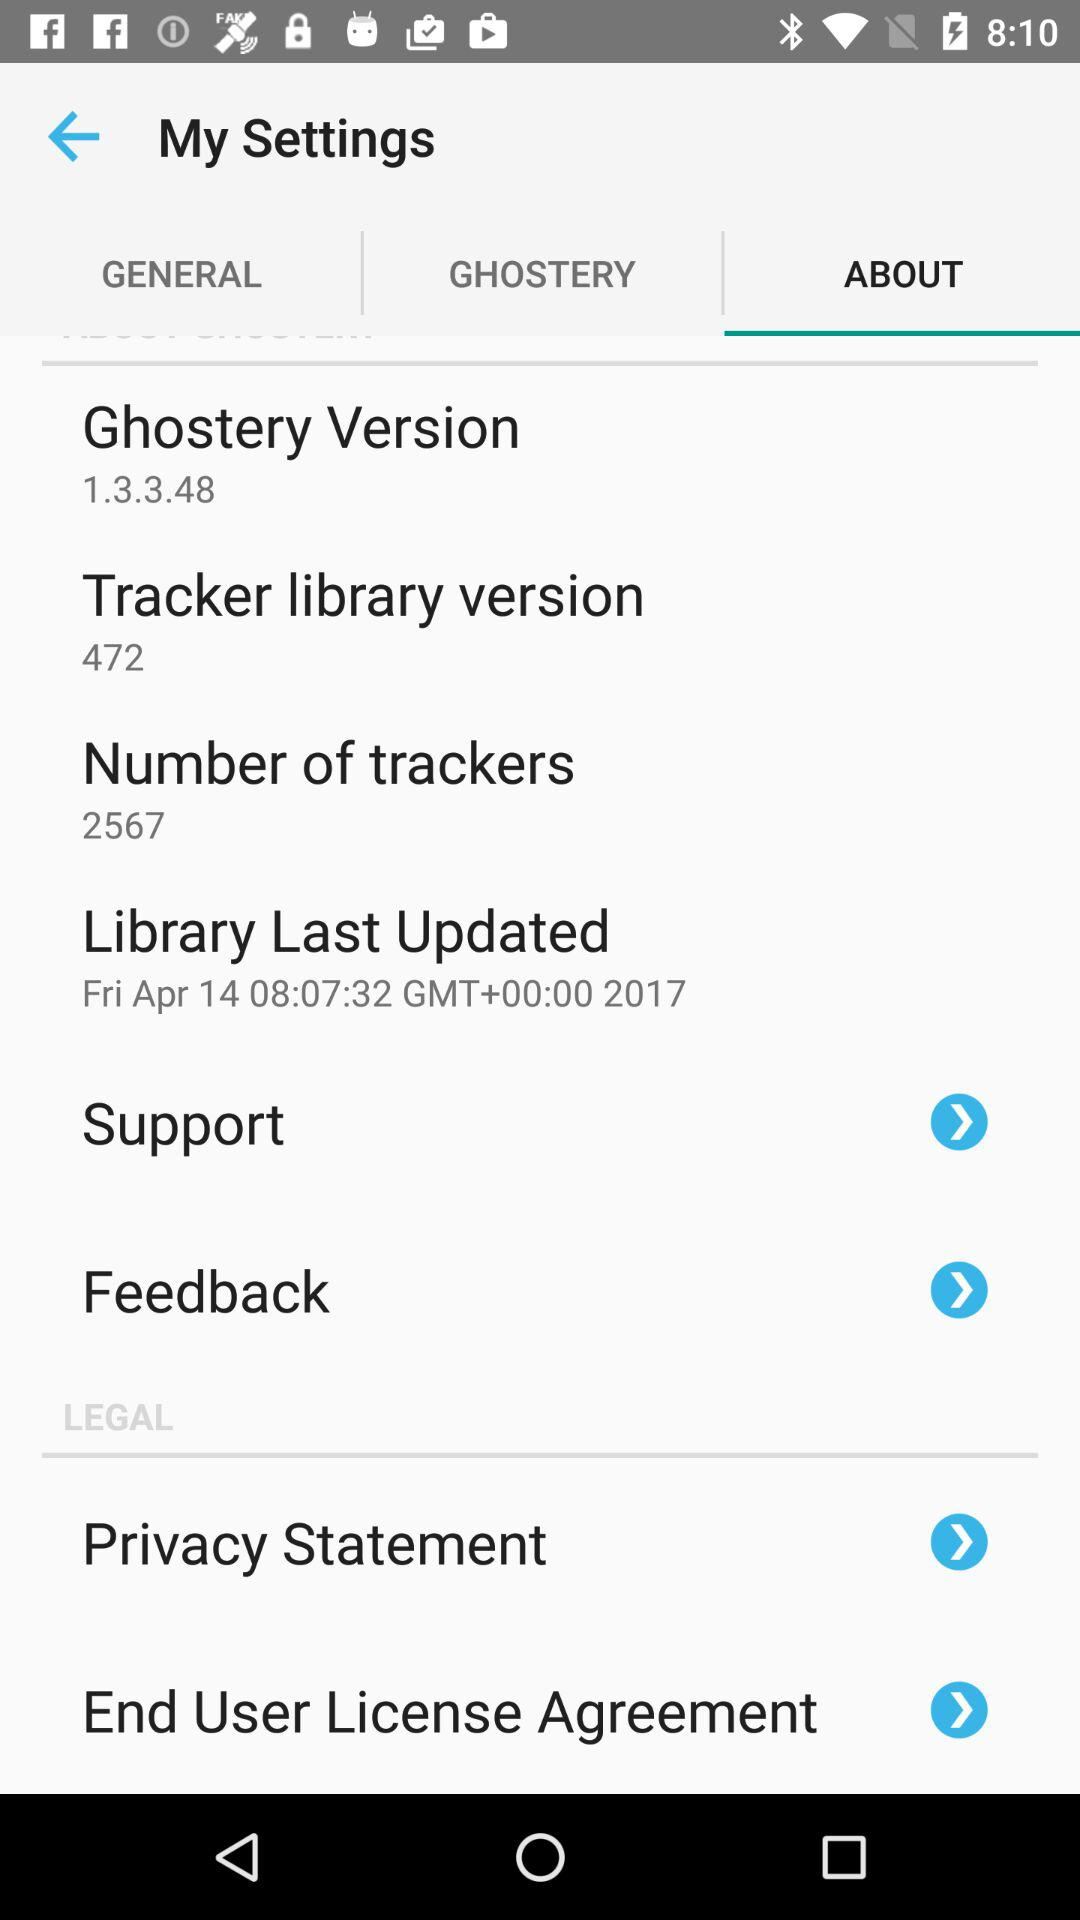What is the Tracker library version? The Tracker library version is 472. 